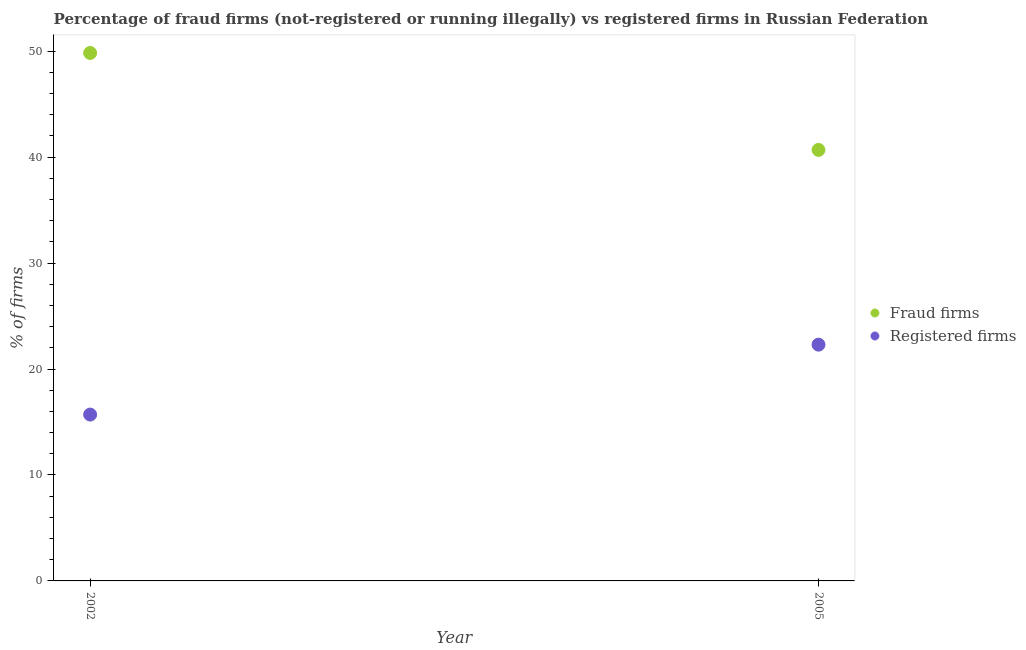Is the number of dotlines equal to the number of legend labels?
Offer a terse response. Yes. What is the percentage of fraud firms in 2002?
Your answer should be compact. 49.83. Across all years, what is the maximum percentage of registered firms?
Give a very brief answer. 22.3. Across all years, what is the minimum percentage of fraud firms?
Offer a terse response. 40.68. In which year was the percentage of fraud firms maximum?
Provide a short and direct response. 2002. In which year was the percentage of registered firms minimum?
Offer a terse response. 2002. What is the total percentage of fraud firms in the graph?
Your answer should be compact. 90.51. What is the difference between the percentage of registered firms in 2002 and that in 2005?
Keep it short and to the point. -6.6. What is the difference between the percentage of fraud firms in 2002 and the percentage of registered firms in 2005?
Your response must be concise. 27.53. What is the average percentage of fraud firms per year?
Make the answer very short. 45.25. In the year 2002, what is the difference between the percentage of fraud firms and percentage of registered firms?
Keep it short and to the point. 34.13. In how many years, is the percentage of fraud firms greater than 32 %?
Give a very brief answer. 2. What is the ratio of the percentage of registered firms in 2002 to that in 2005?
Give a very brief answer. 0.7. Is the percentage of registered firms in 2002 less than that in 2005?
Offer a terse response. Yes. In how many years, is the percentage of fraud firms greater than the average percentage of fraud firms taken over all years?
Your response must be concise. 1. Does the percentage of registered firms monotonically increase over the years?
Make the answer very short. Yes. Is the percentage of fraud firms strictly less than the percentage of registered firms over the years?
Give a very brief answer. No. Are the values on the major ticks of Y-axis written in scientific E-notation?
Your answer should be compact. No. Does the graph contain any zero values?
Make the answer very short. No. Does the graph contain grids?
Your response must be concise. No. How many legend labels are there?
Keep it short and to the point. 2. How are the legend labels stacked?
Provide a succinct answer. Vertical. What is the title of the graph?
Offer a terse response. Percentage of fraud firms (not-registered or running illegally) vs registered firms in Russian Federation. Does "Malaria" appear as one of the legend labels in the graph?
Give a very brief answer. No. What is the label or title of the X-axis?
Ensure brevity in your answer.  Year. What is the label or title of the Y-axis?
Provide a short and direct response. % of firms. What is the % of firms in Fraud firms in 2002?
Offer a terse response. 49.83. What is the % of firms in Fraud firms in 2005?
Offer a very short reply. 40.68. What is the % of firms of Registered firms in 2005?
Keep it short and to the point. 22.3. Across all years, what is the maximum % of firms in Fraud firms?
Offer a very short reply. 49.83. Across all years, what is the maximum % of firms of Registered firms?
Provide a short and direct response. 22.3. Across all years, what is the minimum % of firms in Fraud firms?
Provide a short and direct response. 40.68. What is the total % of firms in Fraud firms in the graph?
Offer a terse response. 90.51. What is the total % of firms in Registered firms in the graph?
Give a very brief answer. 38. What is the difference between the % of firms of Fraud firms in 2002 and that in 2005?
Provide a short and direct response. 9.15. What is the difference between the % of firms in Fraud firms in 2002 and the % of firms in Registered firms in 2005?
Provide a short and direct response. 27.53. What is the average % of firms in Fraud firms per year?
Give a very brief answer. 45.26. In the year 2002, what is the difference between the % of firms in Fraud firms and % of firms in Registered firms?
Provide a short and direct response. 34.13. In the year 2005, what is the difference between the % of firms in Fraud firms and % of firms in Registered firms?
Your answer should be very brief. 18.38. What is the ratio of the % of firms in Fraud firms in 2002 to that in 2005?
Your answer should be compact. 1.22. What is the ratio of the % of firms in Registered firms in 2002 to that in 2005?
Give a very brief answer. 0.7. What is the difference between the highest and the second highest % of firms of Fraud firms?
Make the answer very short. 9.15. What is the difference between the highest and the lowest % of firms of Fraud firms?
Make the answer very short. 9.15. 